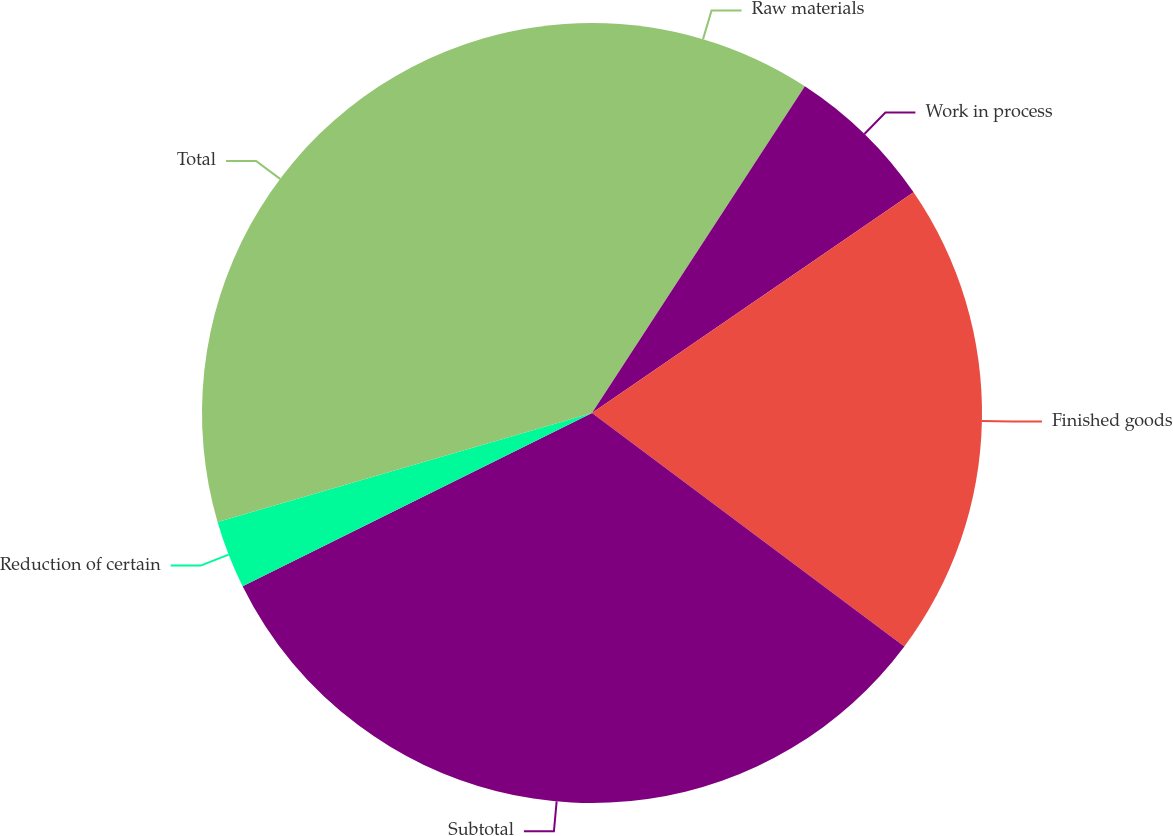<chart> <loc_0><loc_0><loc_500><loc_500><pie_chart><fcel>Raw materials<fcel>Work in process<fcel>Finished goods<fcel>Subtotal<fcel>Reduction of certain<fcel>Total<nl><fcel>9.19%<fcel>6.24%<fcel>19.79%<fcel>32.46%<fcel>2.82%<fcel>29.51%<nl></chart> 